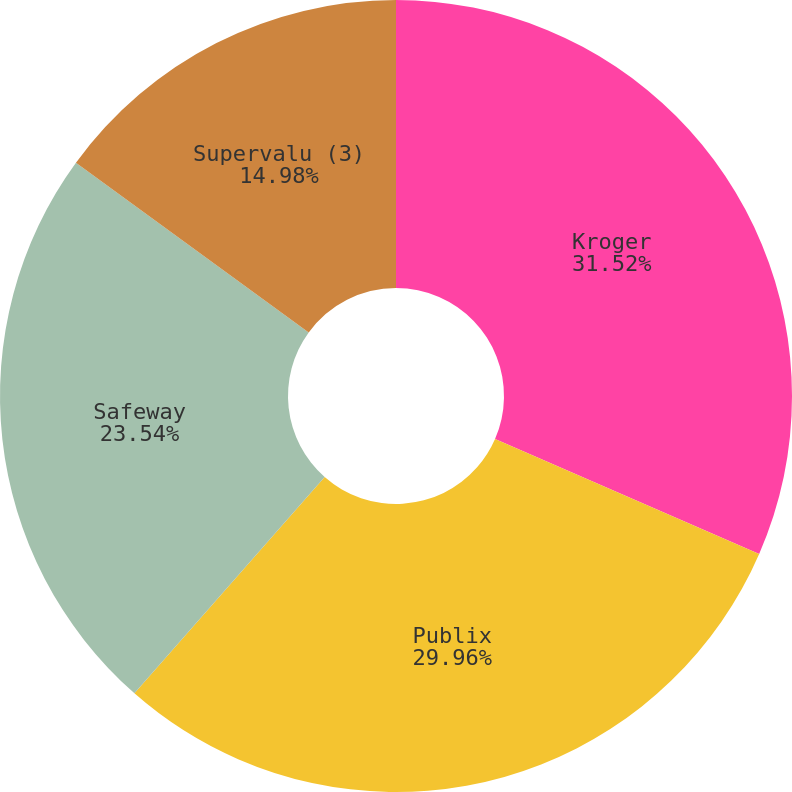<chart> <loc_0><loc_0><loc_500><loc_500><pie_chart><fcel>Kroger<fcel>Publix<fcel>Safeway<fcel>Supervalu (3)<nl><fcel>31.53%<fcel>29.96%<fcel>23.54%<fcel>14.98%<nl></chart> 